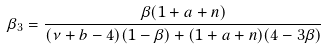<formula> <loc_0><loc_0><loc_500><loc_500>\beta _ { 3 } = \frac { \beta ( 1 + a + n ) } { ( \nu + b - 4 ) ( 1 - \beta ) + ( 1 + a + n ) ( 4 - 3 \beta ) }</formula> 